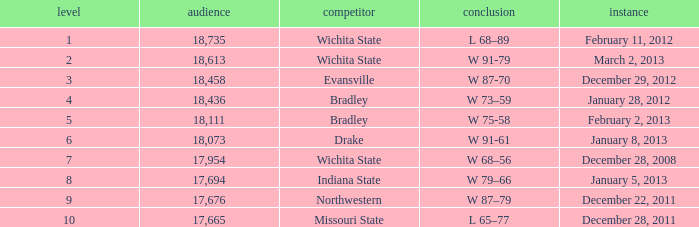What's the rank when attendance was less than 18,073 and having Northwestern as an opponent? 9.0. 